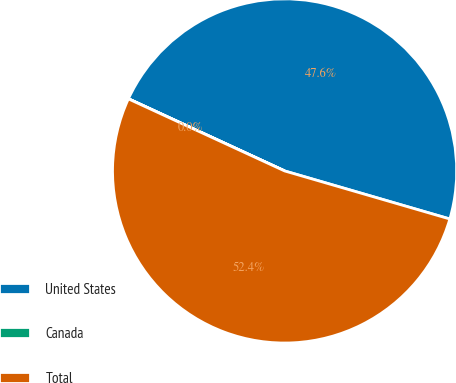Convert chart. <chart><loc_0><loc_0><loc_500><loc_500><pie_chart><fcel>United States<fcel>Canada<fcel>Total<nl><fcel>47.61%<fcel>0.01%<fcel>52.37%<nl></chart> 